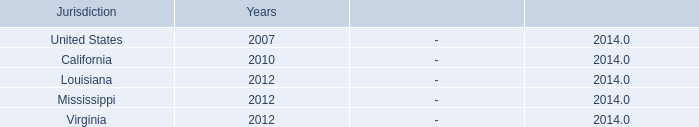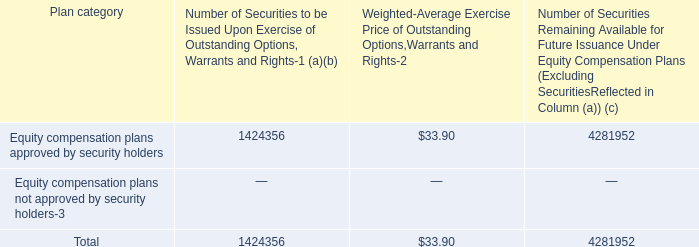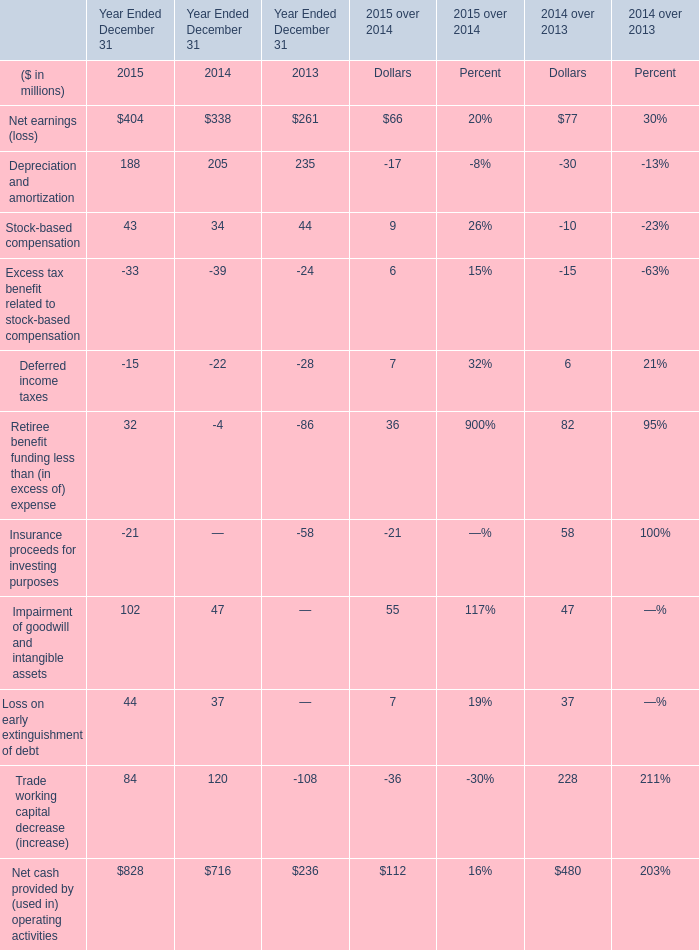what portion of the equity compensation plans approved by security holders remains available for future issuance? 
Computations: (4281952 / (1424356 + 4281952))
Answer: 0.75039. 